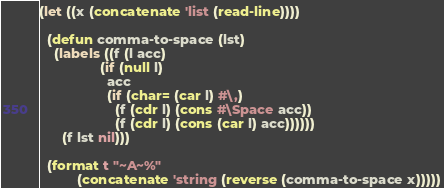Convert code to text. <code><loc_0><loc_0><loc_500><loc_500><_Lisp_>(let ((x (concatenate 'list (read-line))))

  (defun comma-to-space (lst)
    (labels ((f (l acc)
                (if (null l)
                  acc
                  (if (char= (car l) #\,)
                    (f (cdr l) (cons #\Space acc))
                    (f (cdr l) (cons (car l) acc))))))
      (f lst nil)))

  (format t "~A~%"
          (concatenate 'string (reverse (comma-to-space x)))))
</code> 